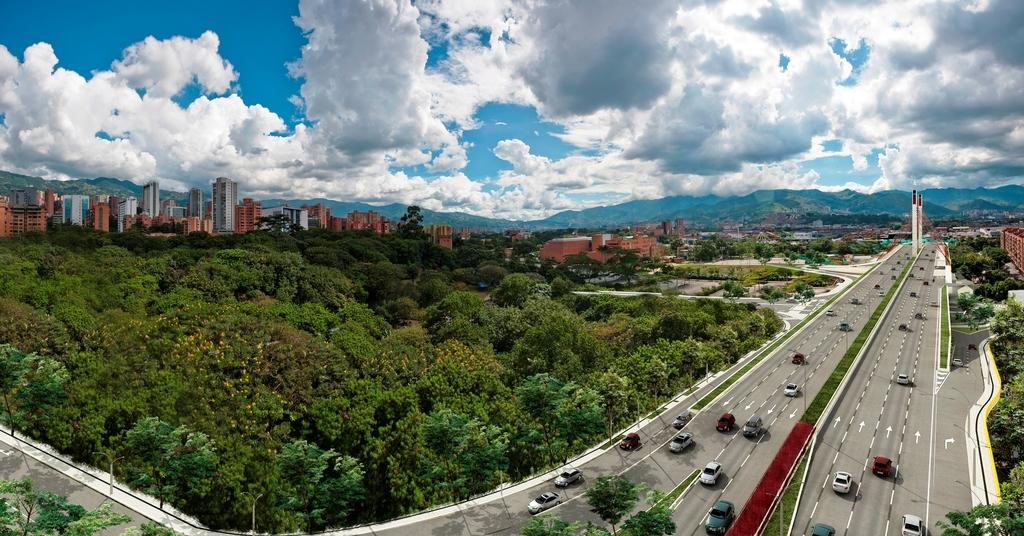What can be seen on the road in the image? There are vehicles on the road in the image. What is visible in the background of the image? There are trees, buildings, and mountains in the background of the image. What part of the natural environment is visible in the image? The sky is visible in the image, and clouds are present in the sky. What type of plants can be seen growing on the pen in the image? There is no pen present in the image, and therefore no plants can be seen growing on it. Is the image taken during the night? No, the image is not taken during the night, as the sky and clouds are visible, which suggests it is daytime. 